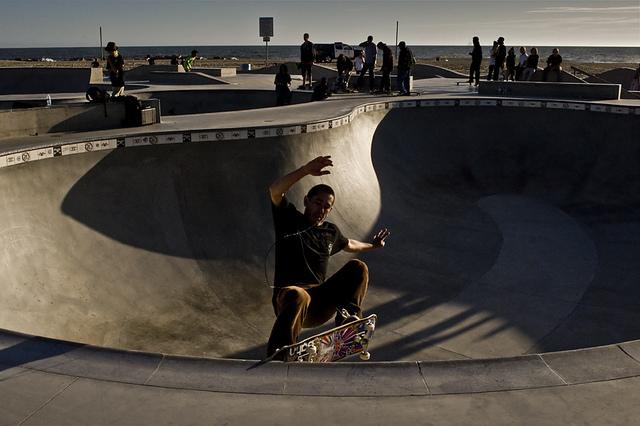How old does the person in the front of the photograph look?
Be succinct. Young. What color are the wheels?
Keep it brief. White. Could this be a skateboard park?
Keep it brief. Yes. 